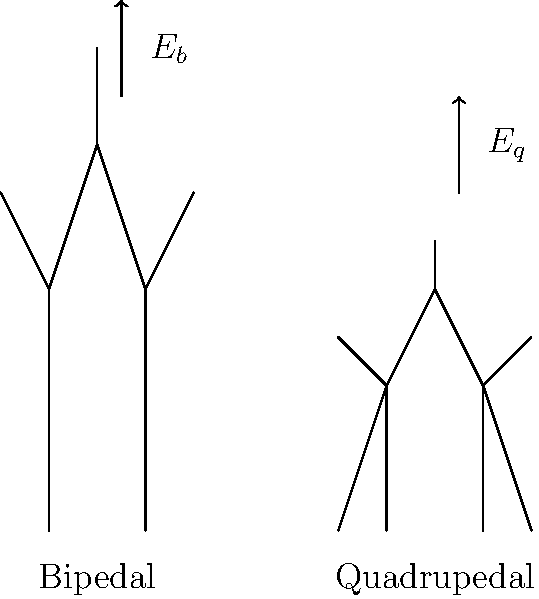Given the skeletal diagrams of bipedal and quadrupedal locomotion, where $E_b$ and $E_q$ represent the energy expenditure for bipedal and quadrupedal movement respectively, which locomotion method is generally more energy-efficient for terrestrial animals? Explain your reasoning using principles of biomechanics and energy conservation. To compare the energy expenditure of bipedal vs. quadrupedal locomotion, we need to consider several factors:

1. Center of Mass (COM) movement:
   - Bipedal locomotion typically involves more vertical COM oscillation.
   - Quadrupedal locomotion maintains a more stable COM height.

2. Energy conversion:
   - In bipedal gait, there's more conversion between potential and kinetic energy.
   - Quadrupedal gait allows for more efficient energy storage in elastic elements (tendons, ligaments).

3. Ground Reaction Forces (GRF):
   - Bipedal locomotion concentrates GRF on two limbs.
   - Quadrupedal locomotion distributes GRF across four limbs, reducing peak forces.

4. Muscle activation:
   - Bipedal locomotion requires more active muscle engagement for balance.
   - Quadrupedal locomotion provides inherent stability, reducing muscle activation needs.

5. Pendulum mechanics:
   - Bipedal gait can utilize inverted pendulum mechanics more effectively.
   - Quadrupedal gait uses a combination of inverted and normal pendulum mechanics.

6. Speed and gait transitions:
   - Bipedal locomotion is generally more efficient at lower speeds.
   - Quadrupedal locomotion allows for more efficient gait transitions (walk, trot, gallop).

7. Body mass considerations:
   - For larger animals, quadrupedal locomotion is generally more efficient due to better weight distribution.

Considering these factors, for most terrestrial animals, quadrupedal locomotion ($E_q$) is generally more energy-efficient than bipedal locomotion ($E_b$). This is primarily due to better stability, more efficient energy storage and return, and reduced muscle activation needs. However, the efficiency can vary depending on speed, body size, and specific adaptations of the species.

The relationship can be expressed as: $E_q < E_b$ for most terrestrial animals.
Answer: Quadrupedal locomotion is generally more energy-efficient ($E_q < E_b$). 